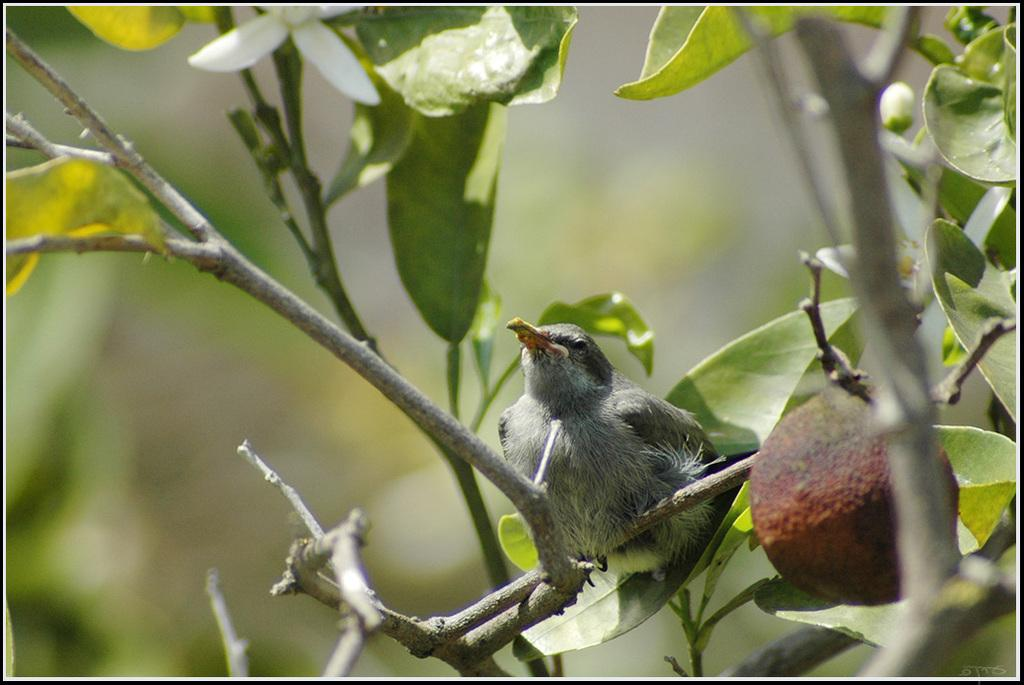What type of animal can be seen in the image? There is a bird in the image. Where is the bird located in the image? The bird is sitting on a branch of a tree. What else can be seen in the image besides the bird? There is a fruit visible in the image. What type of rifle is the bird holding in the image? There is no rifle present in the image; the bird is sitting on a branch of a tree. 